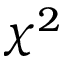Convert formula to latex. <formula><loc_0><loc_0><loc_500><loc_500>\chi ^ { 2 }</formula> 